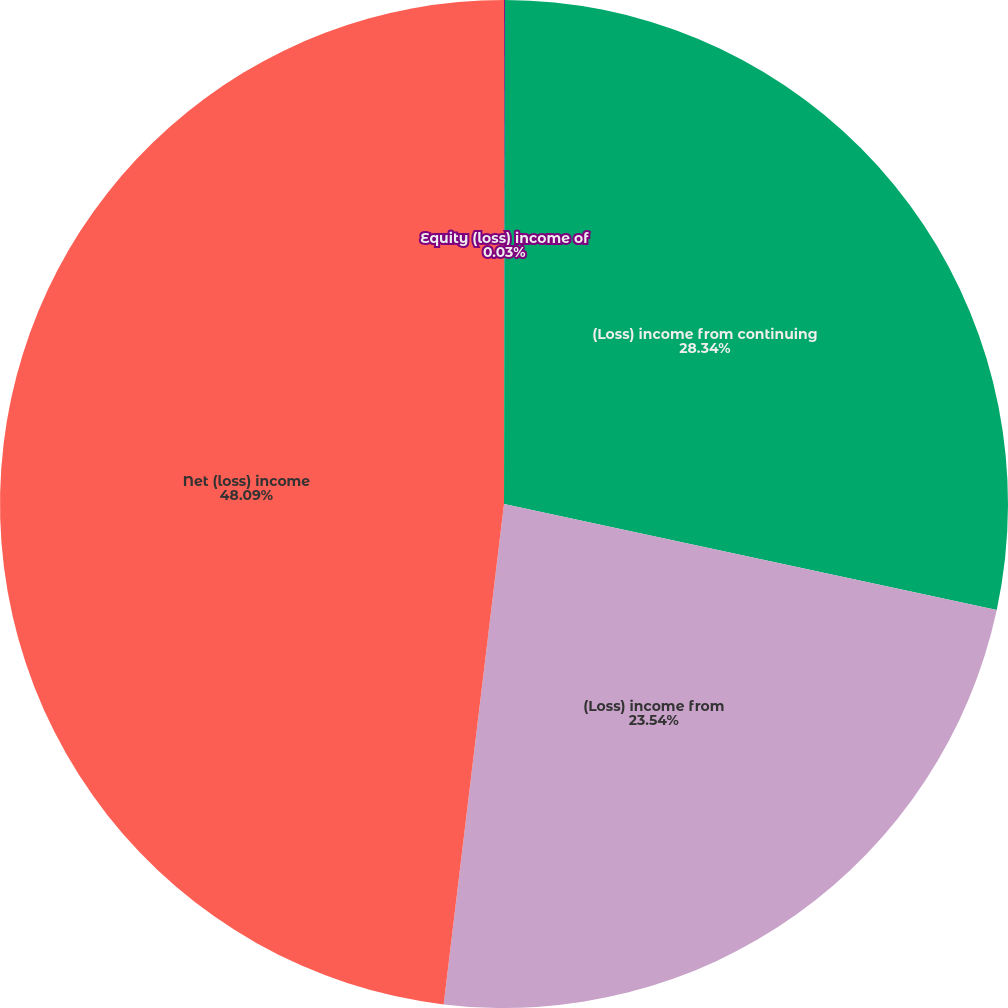<chart> <loc_0><loc_0><loc_500><loc_500><pie_chart><fcel>Equity (loss) income of<fcel>(Loss) income from continuing<fcel>(Loss) income from<fcel>Net (loss) income<nl><fcel>0.03%<fcel>28.34%<fcel>23.54%<fcel>48.09%<nl></chart> 